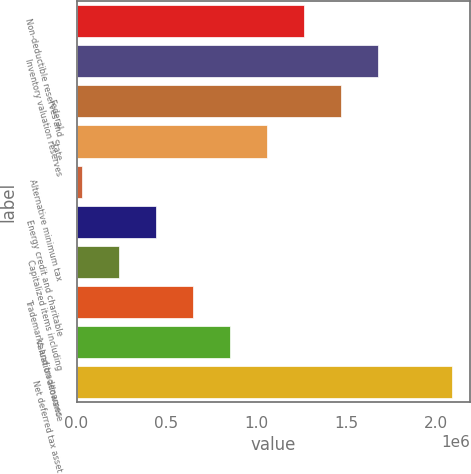Convert chart. <chart><loc_0><loc_0><loc_500><loc_500><bar_chart><fcel>Non-deductible reserves and<fcel>Inventory valuation reserves<fcel>Federal<fcel>State<fcel>Alternative minimum tax<fcel>Energy credit and charitable<fcel>Capitalized items including<fcel>Trademarks and tradenames<fcel>Valuation allowance<fcel>Net deferred tax asset<nl><fcel>1.26353e+06<fcel>1.67514e+06<fcel>1.46933e+06<fcel>1.05772e+06<fcel>28683<fcel>440297<fcel>234490<fcel>646104<fcel>851911<fcel>2.08675e+06<nl></chart> 